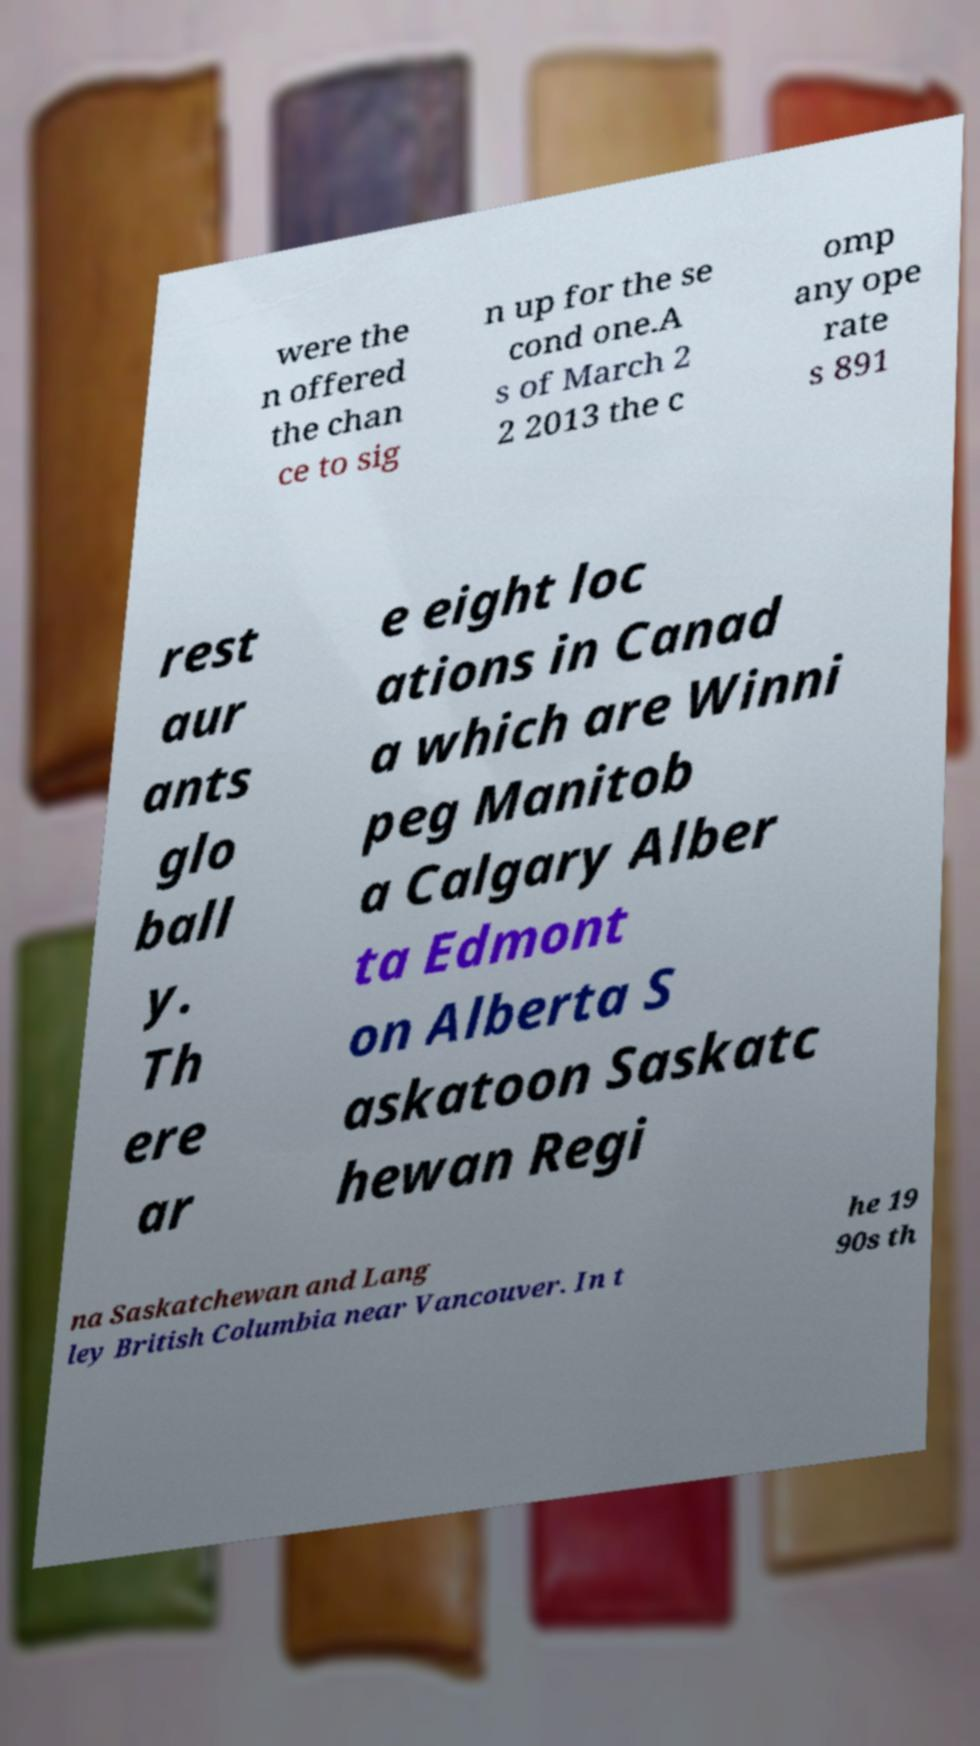What messages or text are displayed in this image? I need them in a readable, typed format. were the n offered the chan ce to sig n up for the se cond one.A s of March 2 2 2013 the c omp any ope rate s 891 rest aur ants glo ball y. Th ere ar e eight loc ations in Canad a which are Winni peg Manitob a Calgary Alber ta Edmont on Alberta S askatoon Saskatc hewan Regi na Saskatchewan and Lang ley British Columbia near Vancouver. In t he 19 90s th 